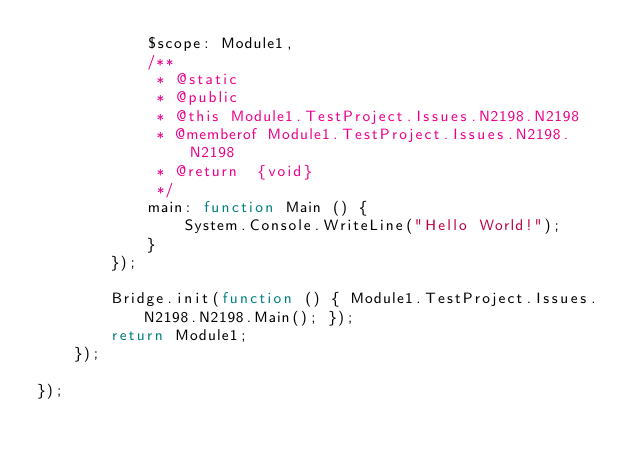<code> <loc_0><loc_0><loc_500><loc_500><_JavaScript_>            $scope: Module1,
            /**
             * @static
             * @public
             * @this Module1.TestProject.Issues.N2198.N2198
             * @memberof Module1.TestProject.Issues.N2198.N2198
             * @return  {void}
             */
            main: function Main () {
                System.Console.WriteLine("Hello World!");
            }
        });

        Bridge.init(function () { Module1.TestProject.Issues.N2198.N2198.Main(); });
        return Module1;
    });

});
</code> 